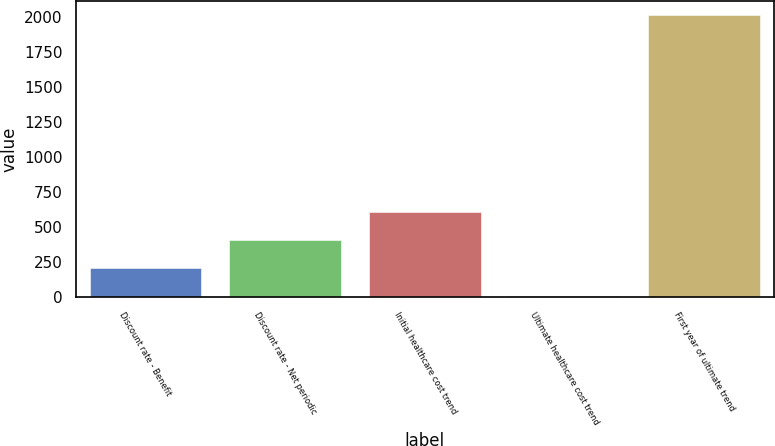Convert chart. <chart><loc_0><loc_0><loc_500><loc_500><bar_chart><fcel>Discount rate - Benefit<fcel>Discount rate - Net periodic<fcel>Initial healthcare cost trend<fcel>Ultimate healthcare cost trend<fcel>First year of ultimate trend<nl><fcel>205.9<fcel>406.8<fcel>607.7<fcel>5<fcel>2014<nl></chart> 